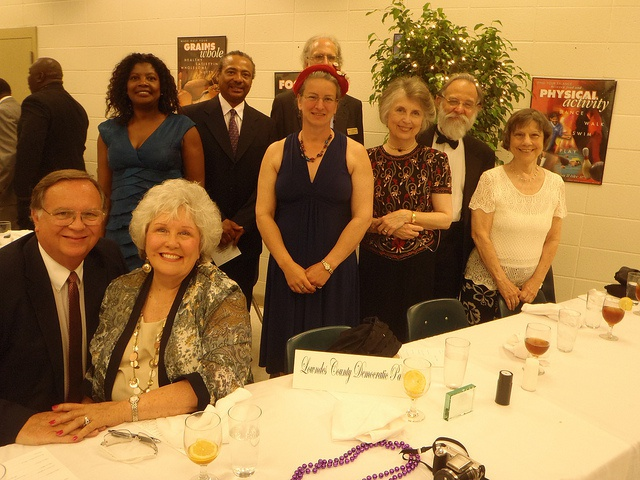Describe the objects in this image and their specific colors. I can see dining table in tan, khaki, gold, and maroon tones, people in tan, olive, orange, and black tones, people in tan, black, red, and orange tones, people in tan, black, brown, red, and maroon tones, and people in tan, black, brown, maroon, and orange tones in this image. 